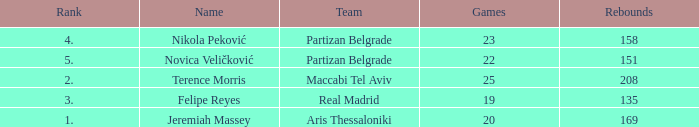Could you parse the entire table? {'header': ['Rank', 'Name', 'Team', 'Games', 'Rebounds'], 'rows': [['4.', 'Nikola Peković', 'Partizan Belgrade', '23', '158'], ['5.', 'Novica Veličković', 'Partizan Belgrade', '22', '151'], ['2.', 'Terence Morris', 'Maccabi Tel Aviv', '25', '208'], ['3.', 'Felipe Reyes', 'Real Madrid', '19', '135'], ['1.', 'Jeremiah Massey', 'Aris Thessaloniki', '20', '169']]} What is the number of Games for the Maccabi Tel Aviv Team with less than 208 Rebounds? None. 